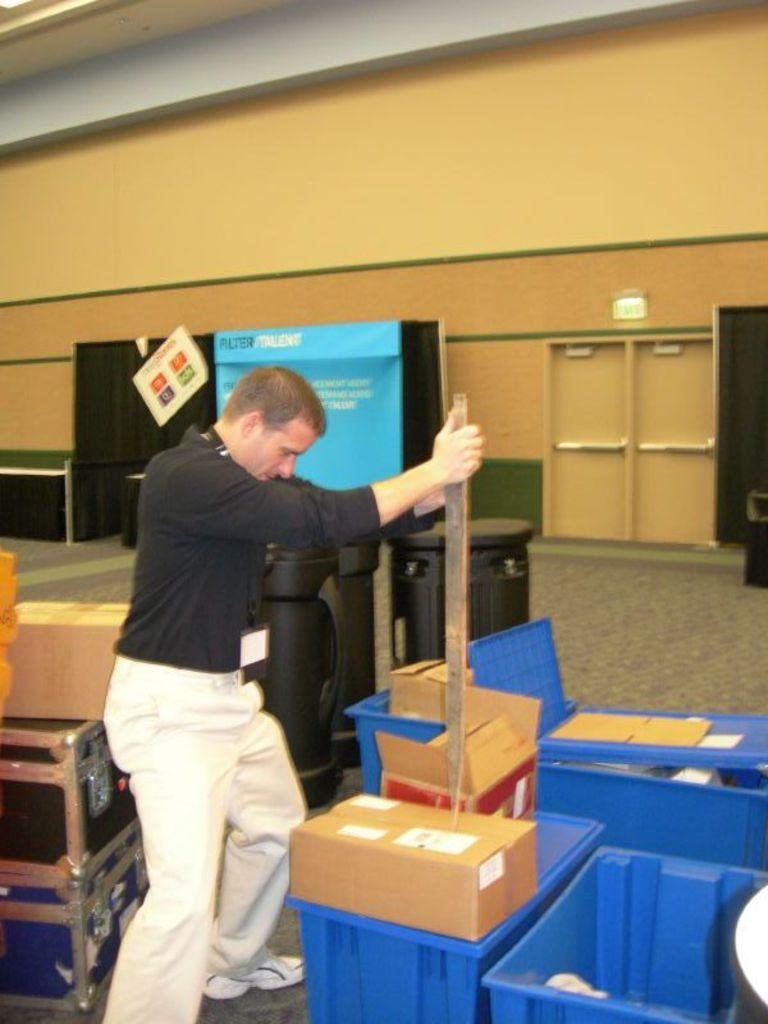Can you describe this image briefly? In this image there is a person standing, holding a sharp object in his hand, the person is trying to open a cardboard box with this sharp object, around him there are few plastic boxes and cardboard boxes. 